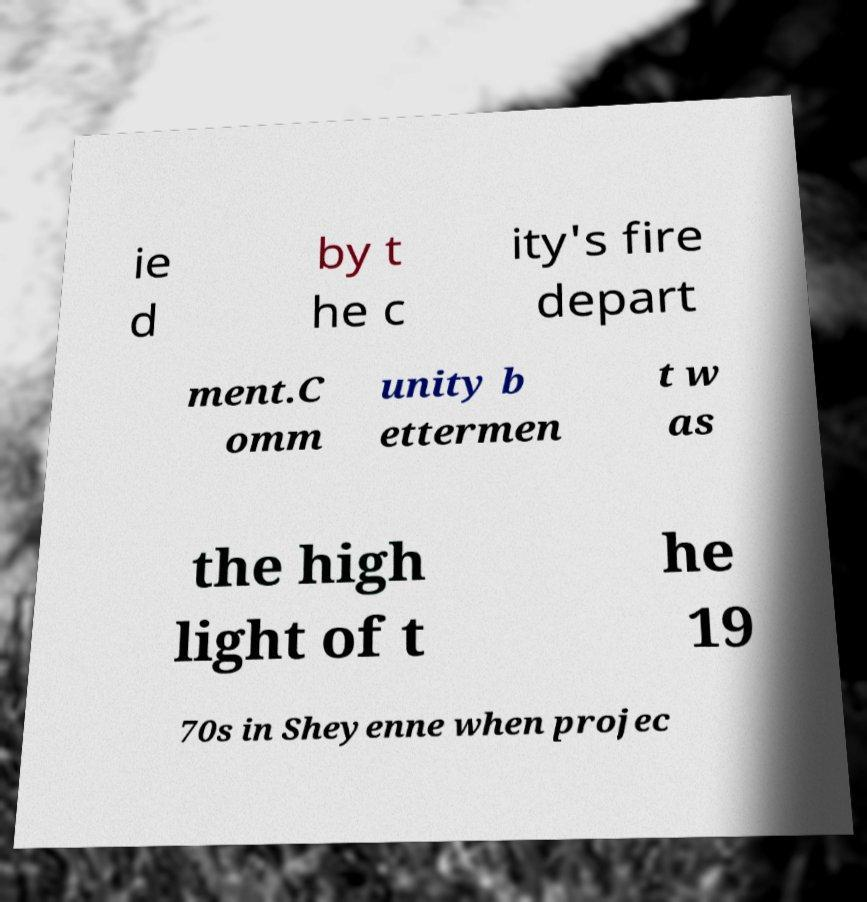What messages or text are displayed in this image? I need them in a readable, typed format. ie d by t he c ity's fire depart ment.C omm unity b ettermen t w as the high light of t he 19 70s in Sheyenne when projec 